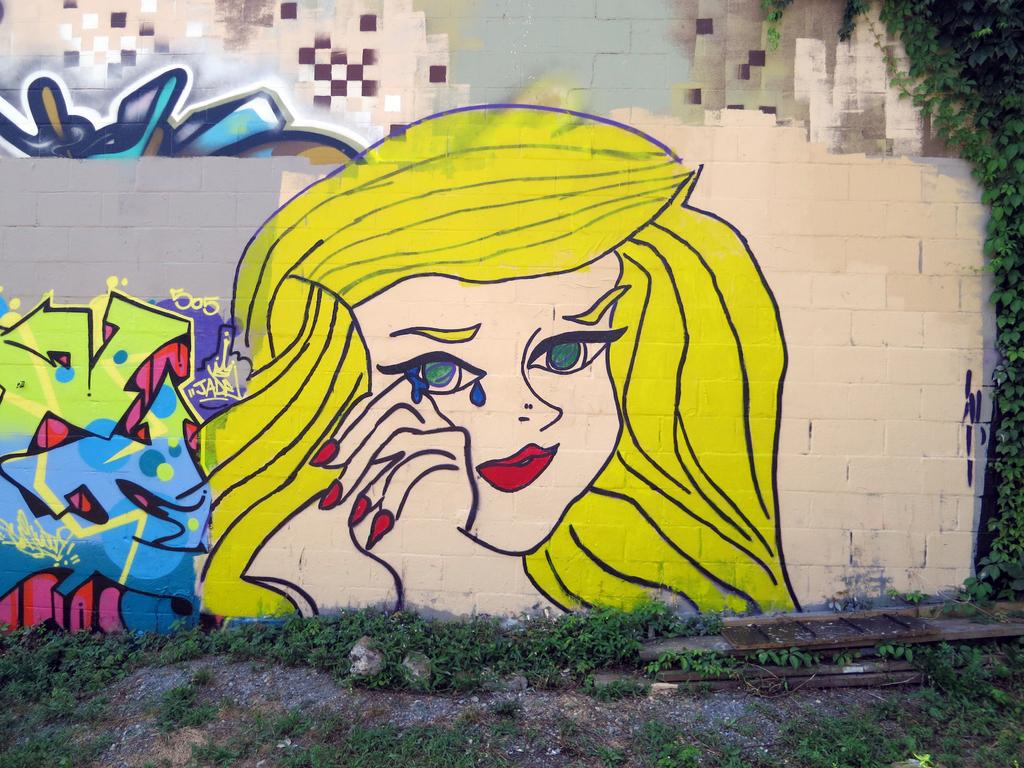What is depicted on the wall in the image? A girl is painted on the wall in the image. What is the surface beneath the wall in the image? There is a ground in the image. What type of vegetation is present on the ground? Grass is present on the ground in the image. What else can be seen on the ground besides grass? Stones are visible on the ground in the image. What type of feast is being prepared on the ground in the image? There is no feast being prepared in the image; it only shows a painted girl on the wall, a ground with grass and stones. 